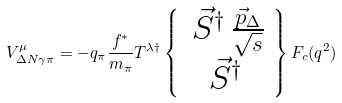<formula> <loc_0><loc_0><loc_500><loc_500>V ^ { \mu } _ { \Delta N \gamma \pi } = - q _ { \pi } \frac { f ^ { \ast } } { m _ { \pi } } T ^ { \lambda \dagger } \left \{ \begin{array} { c } \, \vec { S } ^ { \dagger } \, \frac { \vec { p } _ { \Delta } } { \sqrt { s } } \\ \vec { S } ^ { \dagger } \end{array} \right \} F _ { c } ( q ^ { 2 } )</formula> 